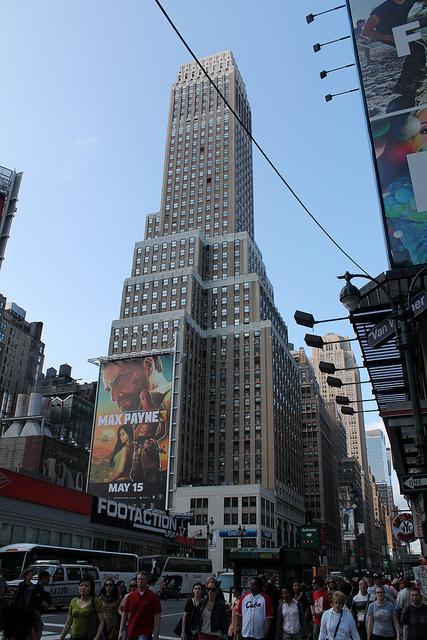What movie is on the poster?
Write a very short answer. Max payne. How many tiers does the building have?
Write a very short answer. 4. What kind of buildings are shown?
Concise answer only. Skyscrapers. Is the building old?
Be succinct. Yes. Are the buildings smaller towards the top?
Quick response, please. Yes. What city is this?
Be succinct. New york. 